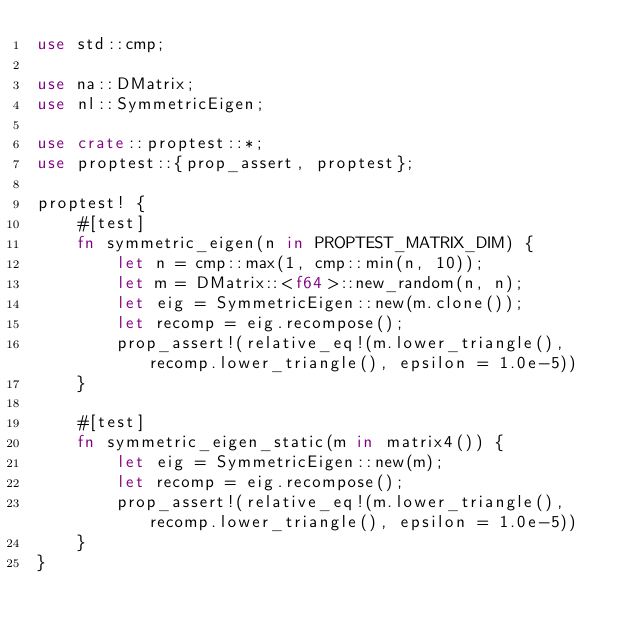<code> <loc_0><loc_0><loc_500><loc_500><_Rust_>use std::cmp;

use na::DMatrix;
use nl::SymmetricEigen;

use crate::proptest::*;
use proptest::{prop_assert, proptest};

proptest! {
    #[test]
    fn symmetric_eigen(n in PROPTEST_MATRIX_DIM) {
        let n = cmp::max(1, cmp::min(n, 10));
        let m = DMatrix::<f64>::new_random(n, n);
        let eig = SymmetricEigen::new(m.clone());
        let recomp = eig.recompose();
        prop_assert!(relative_eq!(m.lower_triangle(), recomp.lower_triangle(), epsilon = 1.0e-5))
    }

    #[test]
    fn symmetric_eigen_static(m in matrix4()) {
        let eig = SymmetricEigen::new(m);
        let recomp = eig.recompose();
        prop_assert!(relative_eq!(m.lower_triangle(), recomp.lower_triangle(), epsilon = 1.0e-5))
    }
}
</code> 